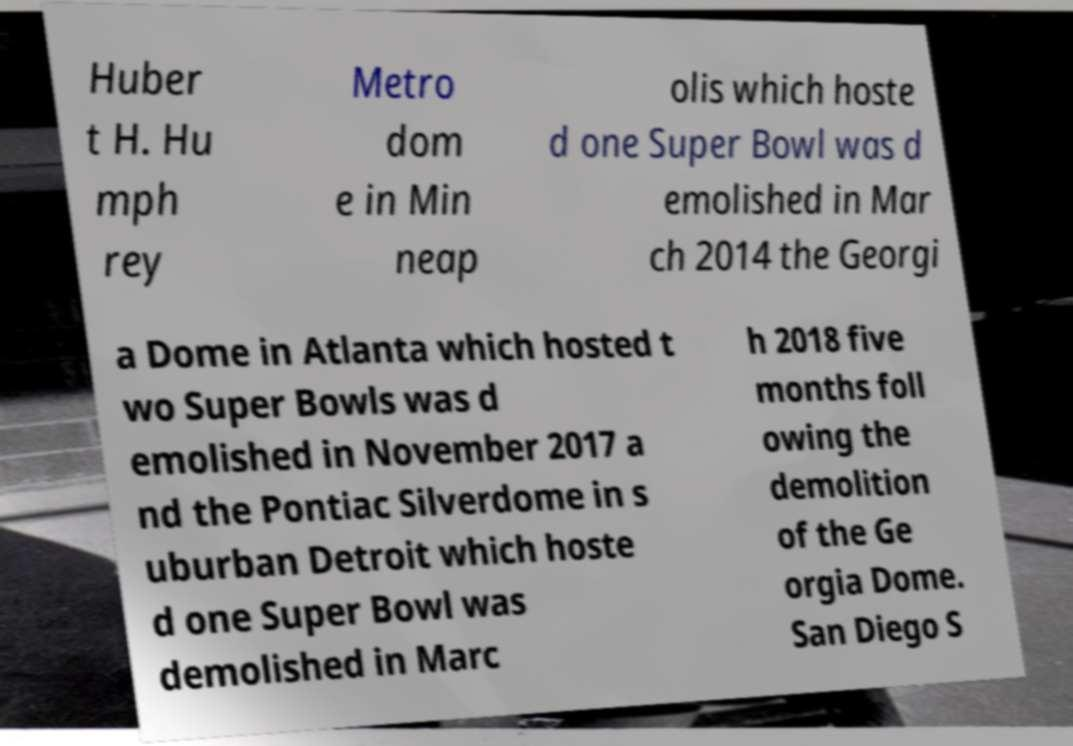Can you accurately transcribe the text from the provided image for me? Huber t H. Hu mph rey Metro dom e in Min neap olis which hoste d one Super Bowl was d emolished in Mar ch 2014 the Georgi a Dome in Atlanta which hosted t wo Super Bowls was d emolished in November 2017 a nd the Pontiac Silverdome in s uburban Detroit which hoste d one Super Bowl was demolished in Marc h 2018 five months foll owing the demolition of the Ge orgia Dome. San Diego S 